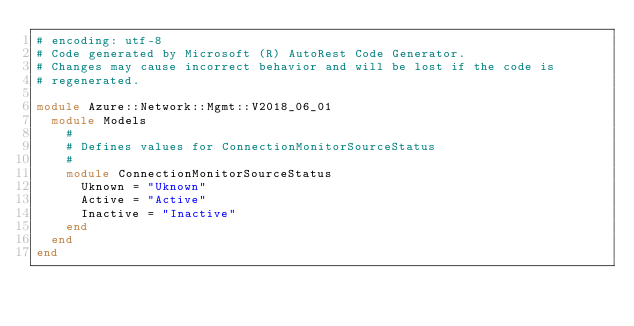Convert code to text. <code><loc_0><loc_0><loc_500><loc_500><_Ruby_># encoding: utf-8
# Code generated by Microsoft (R) AutoRest Code Generator.
# Changes may cause incorrect behavior and will be lost if the code is
# regenerated.

module Azure::Network::Mgmt::V2018_06_01
  module Models
    #
    # Defines values for ConnectionMonitorSourceStatus
    #
    module ConnectionMonitorSourceStatus
      Uknown = "Uknown"
      Active = "Active"
      Inactive = "Inactive"
    end
  end
end
</code> 